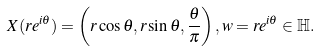Convert formula to latex. <formula><loc_0><loc_0><loc_500><loc_500>X ( r e ^ { i \theta } ) = \left ( r \cos { \theta } , r \sin { \theta } , \frac { \theta } { \pi } \right ) , w = r e ^ { i \theta } \in \mathbb { H } .</formula> 